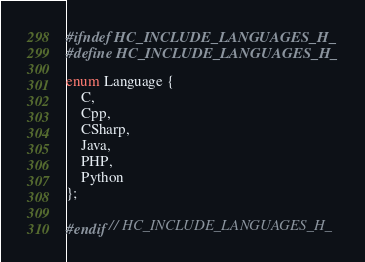<code> <loc_0><loc_0><loc_500><loc_500><_C_>#ifndef HC_INCLUDE_LANGUAGES_H_
#define HC_INCLUDE_LANGUAGES_H_

enum Language {
    C,
    Cpp,
    CSharp,
    Java,
    PHP,
    Python
};

#endif // HC_INCLUDE_LANGUAGES_H_
</code> 